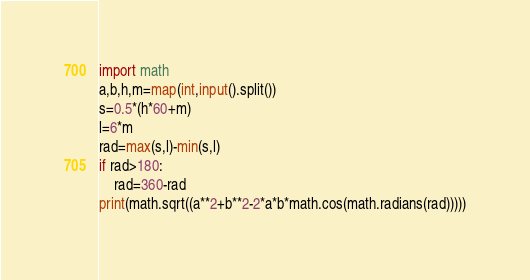<code> <loc_0><loc_0><loc_500><loc_500><_Python_>import math
a,b,h,m=map(int,input().split())
s=0.5*(h*60+m)
l=6*m
rad=max(s,l)-min(s,l)
if rad>180:
    rad=360-rad
print(math.sqrt((a**2+b**2-2*a*b*math.cos(math.radians(rad)))))</code> 